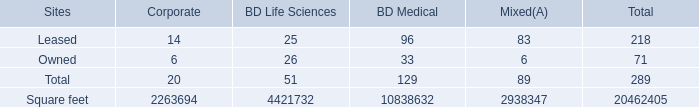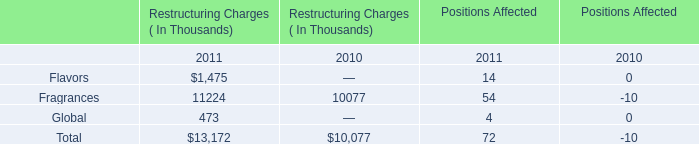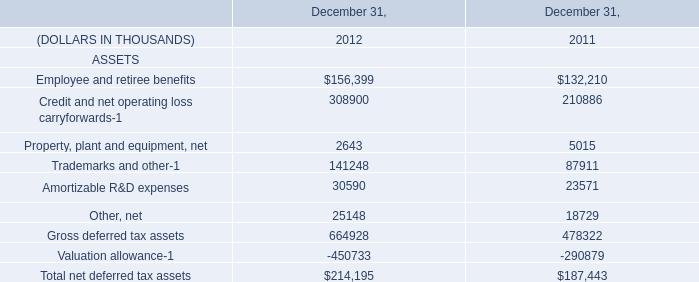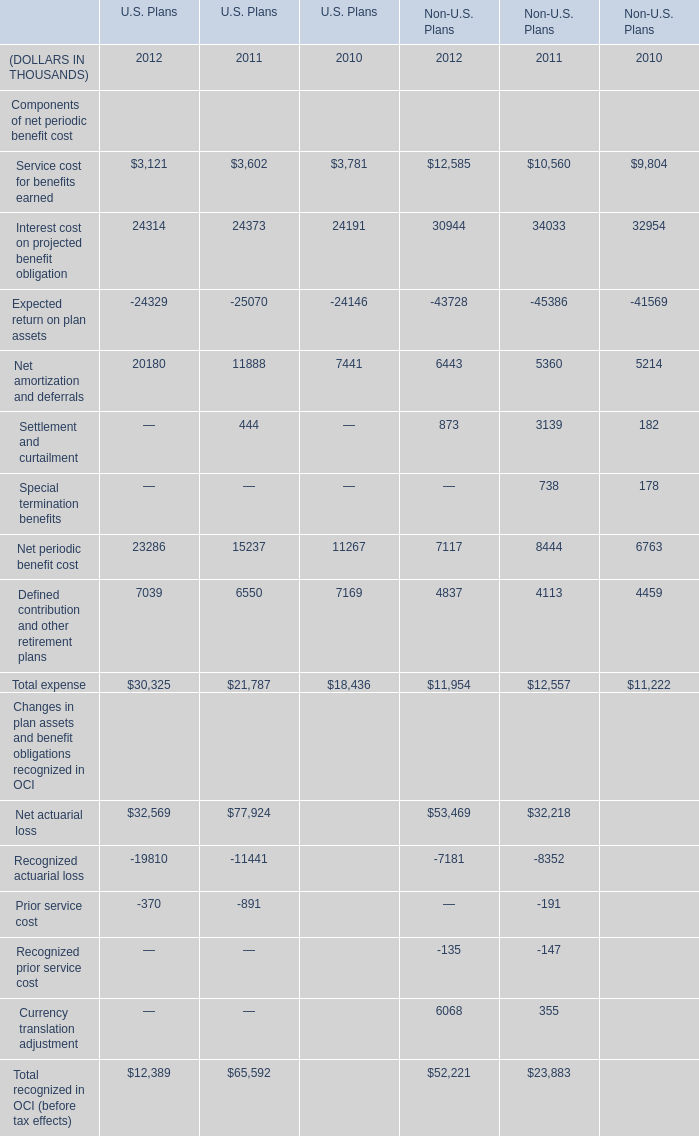In terms of U.S. Plans,what do all Net periodic benefit cost sum up without the Net periodic benefit cost that is smaller than 20000 THOUSAND? (in thousand) 
Answer: 23286. 